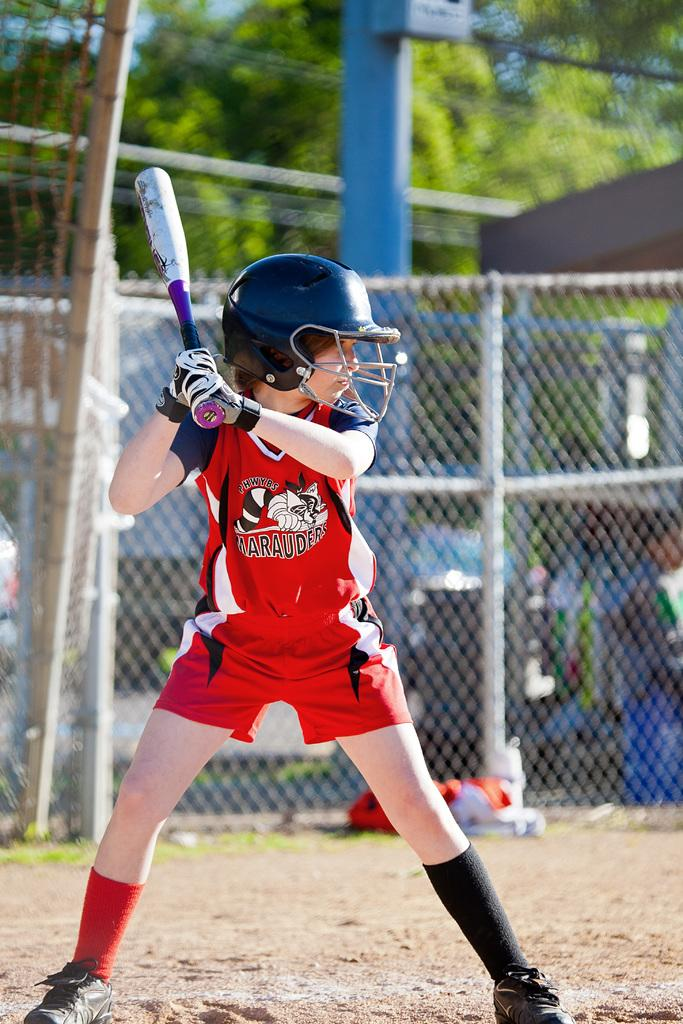Who is in the image? There is a boy in the image. What is the boy doing in the image? The boy is standing on the floor and holding a bat. What protective gear is the boy wearing? The boy is wearing a helmet. What can be seen in the background of the image? There are trees and a fence visible in the background of the image. What type of jellyfish can be seen swimming in the alley behind the boy? There is no jellyfish present in the image, nor is there an alley visible. 